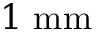<formula> <loc_0><loc_0><loc_500><loc_500>1 m m</formula> 